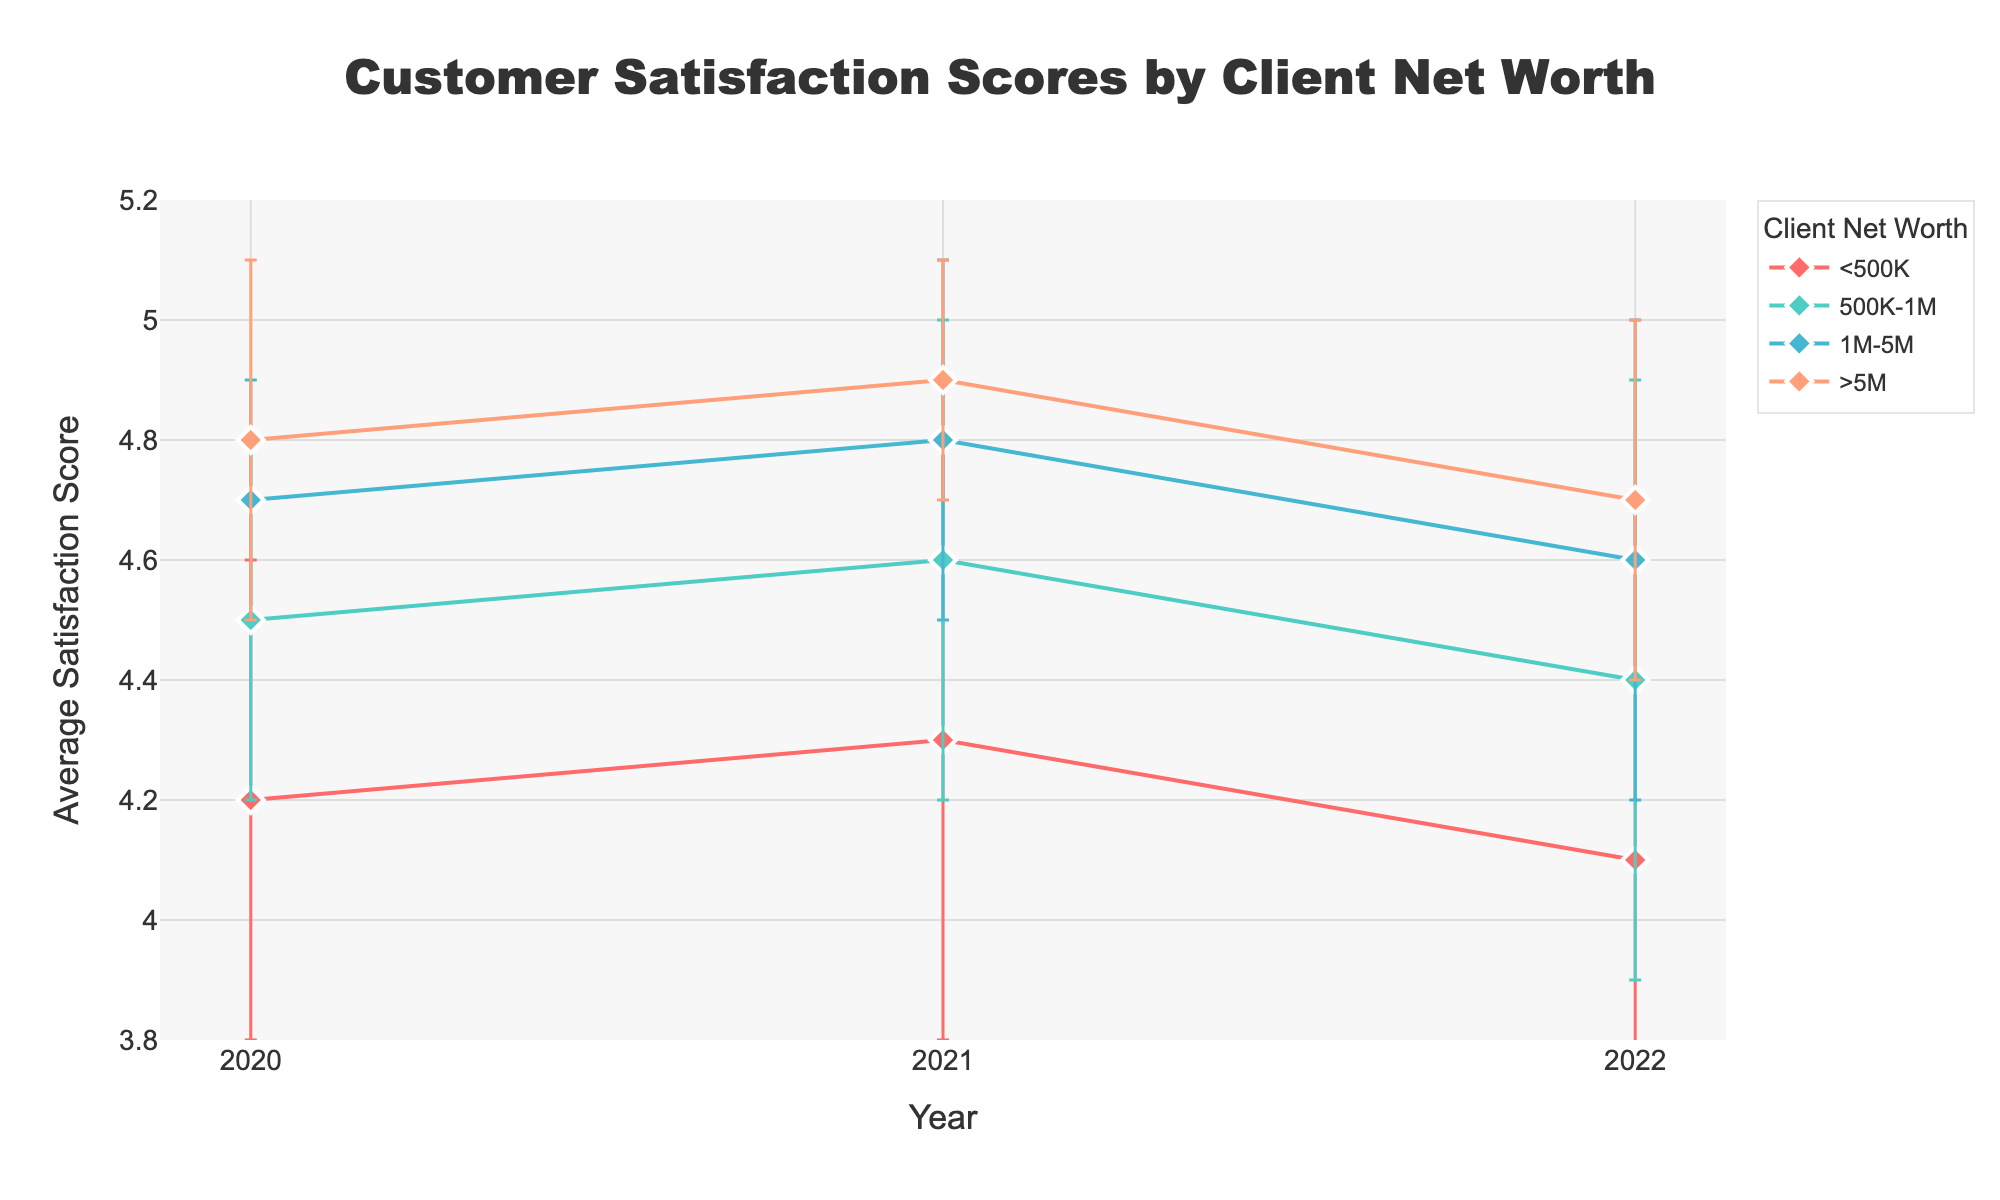What is the title of the figure? The title is located at the top center of the figure, showing the primary subject being visualized. It is specified in a larger font size for better visibility.
Answer: Customer Satisfaction Scores by Client Net Worth What is the average satisfaction score for clients with a net worth greater than 5M in 2021? Locate the data points for the year 2021 and identify the score corresponding to the '>5M' net worth category.
Answer: 4.9 How did the average satisfaction score for clients with net worth between 1M-5M change from 2020 to 2022? Compare the data points for clients with 1M-5M net worth in 2020 and 2022. The score was 4.7 in 2020 and 4.6 in 2022, indicating a decline.
Answer: Decreased by 0.1 Which client net worth category experienced the most significant drop in average satisfaction scores from 2021 to 2022? Compare the score differences between 2021 and 2022 for each category: <500K dropped from 4.3 to 4.1 (0.2), 500K-1M from 4.6 to 4.4 (0.2), 1M-5M from 4.8 to 4.6 (0.2), and >5M from 4.9 to 4.7 (0.2). All segments show an equal drop.
Answer: All categories experienced a drop of 0.2 Which category consistently had the highest satisfaction scores over the three years? Examine the data points for each year and each category to see which category has the highest values consistently across all years.
Answer: >5M What was the change in satisfaction score for the <500K category from 2020 to 2021? Locate the satisfaction scores for <500K in 2020 and 2021. The score increased from 4.2 to 4.3, resulting in a change of +0.1.
Answer: Increased by 0.1 Calculate the average satisfaction score for the 500K-1M category over the three years. Add the scores for the 500K-1M category for each year (4.5 in 2020, 4.6 in 2021, and 4.4 in 2022) and then divide by 3 to find the average. The calculation is (4.5 + 4.6 + 4.4) / 3 = 4.5.
Answer: 4.5 Which year saw the highest average satisfaction scores for clients with a net worth between 500K-1M? Examine the satisfaction scores for the 500K-1M category across 2020, 2021, and 2022. The highest score is 4.6 in 2021.
Answer: 2021 How many unique client net worth categories are displayed in the figure? Count the distinct categories of client net worth shown: <500K, 500K-1M, 1M-5M, and >5M.
Answer: 4 